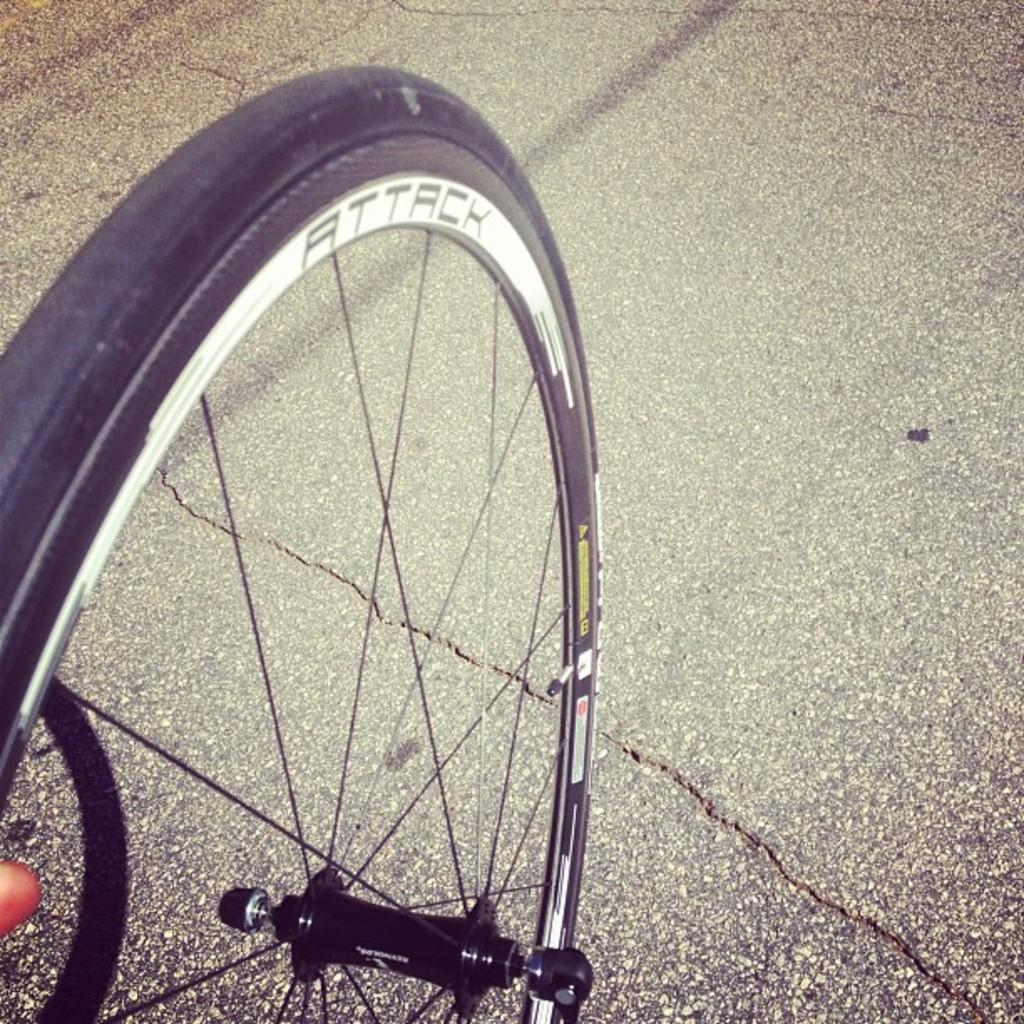What object is present in the image that has a circular shape? There is a wheel in the image. What type of surface can be seen in the image? There is a road in the image. Can you identify any human elements in the image? Yes, there is a finger of a person at the left side of the image. What type of house can be seen in the image? There is no house present in the image; it only features a wheel, a road, and a finger. What sense is being used by the person in the image? The image does not provide information about the person's senses or actions, so it cannot be determined which sense is being used. 